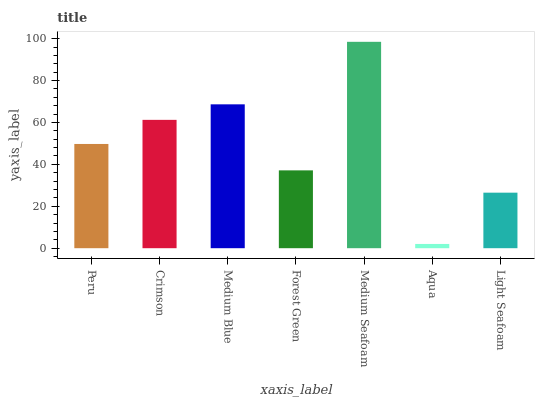Is Aqua the minimum?
Answer yes or no. Yes. Is Medium Seafoam the maximum?
Answer yes or no. Yes. Is Crimson the minimum?
Answer yes or no. No. Is Crimson the maximum?
Answer yes or no. No. Is Crimson greater than Peru?
Answer yes or no. Yes. Is Peru less than Crimson?
Answer yes or no. Yes. Is Peru greater than Crimson?
Answer yes or no. No. Is Crimson less than Peru?
Answer yes or no. No. Is Peru the high median?
Answer yes or no. Yes. Is Peru the low median?
Answer yes or no. Yes. Is Aqua the high median?
Answer yes or no. No. Is Crimson the low median?
Answer yes or no. No. 